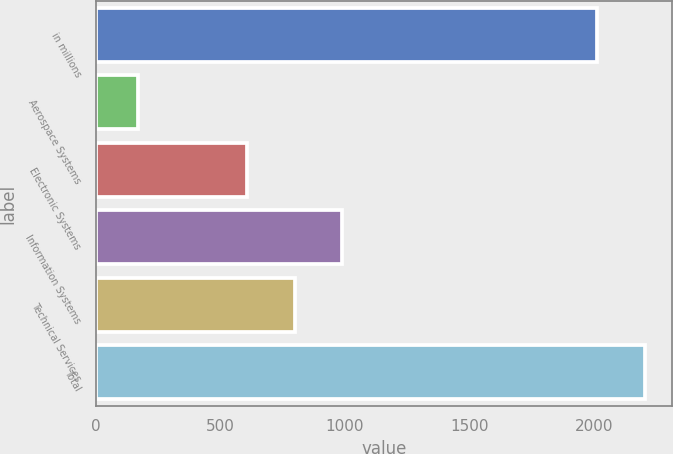Convert chart to OTSL. <chart><loc_0><loc_0><loc_500><loc_500><bar_chart><fcel>in millions<fcel>Aerospace Systems<fcel>Electronic Systems<fcel>Information Systems<fcel>Technical Services<fcel>Total<nl><fcel>2012<fcel>171<fcel>607<fcel>989.6<fcel>798.3<fcel>2203.3<nl></chart> 